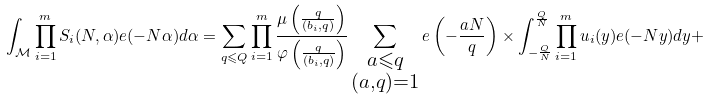<formula> <loc_0><loc_0><loc_500><loc_500>\int _ { \mathcal { M } } \prod _ { i = 1 } ^ { m } S _ { i } ( N , \alpha ) e ( - N \alpha ) d \alpha = \sum _ { q \leqslant Q } \prod _ { i = 1 } ^ { m } \frac { \mu \left ( \frac { q } { ( b _ { i } , q ) } \right ) } { \varphi \left ( \frac { q } { ( b _ { i } , q ) } \right ) } \sum _ { \substack { a \leqslant q \\ ( a , q ) = 1 } } e \left ( - \frac { a N } { q } \right ) \times \int _ { - \frac { Q } { N } } ^ { \frac { Q } { N } } \prod _ { i = 1 } ^ { m } u _ { i } ( y ) e ( - N y ) d y +</formula> 